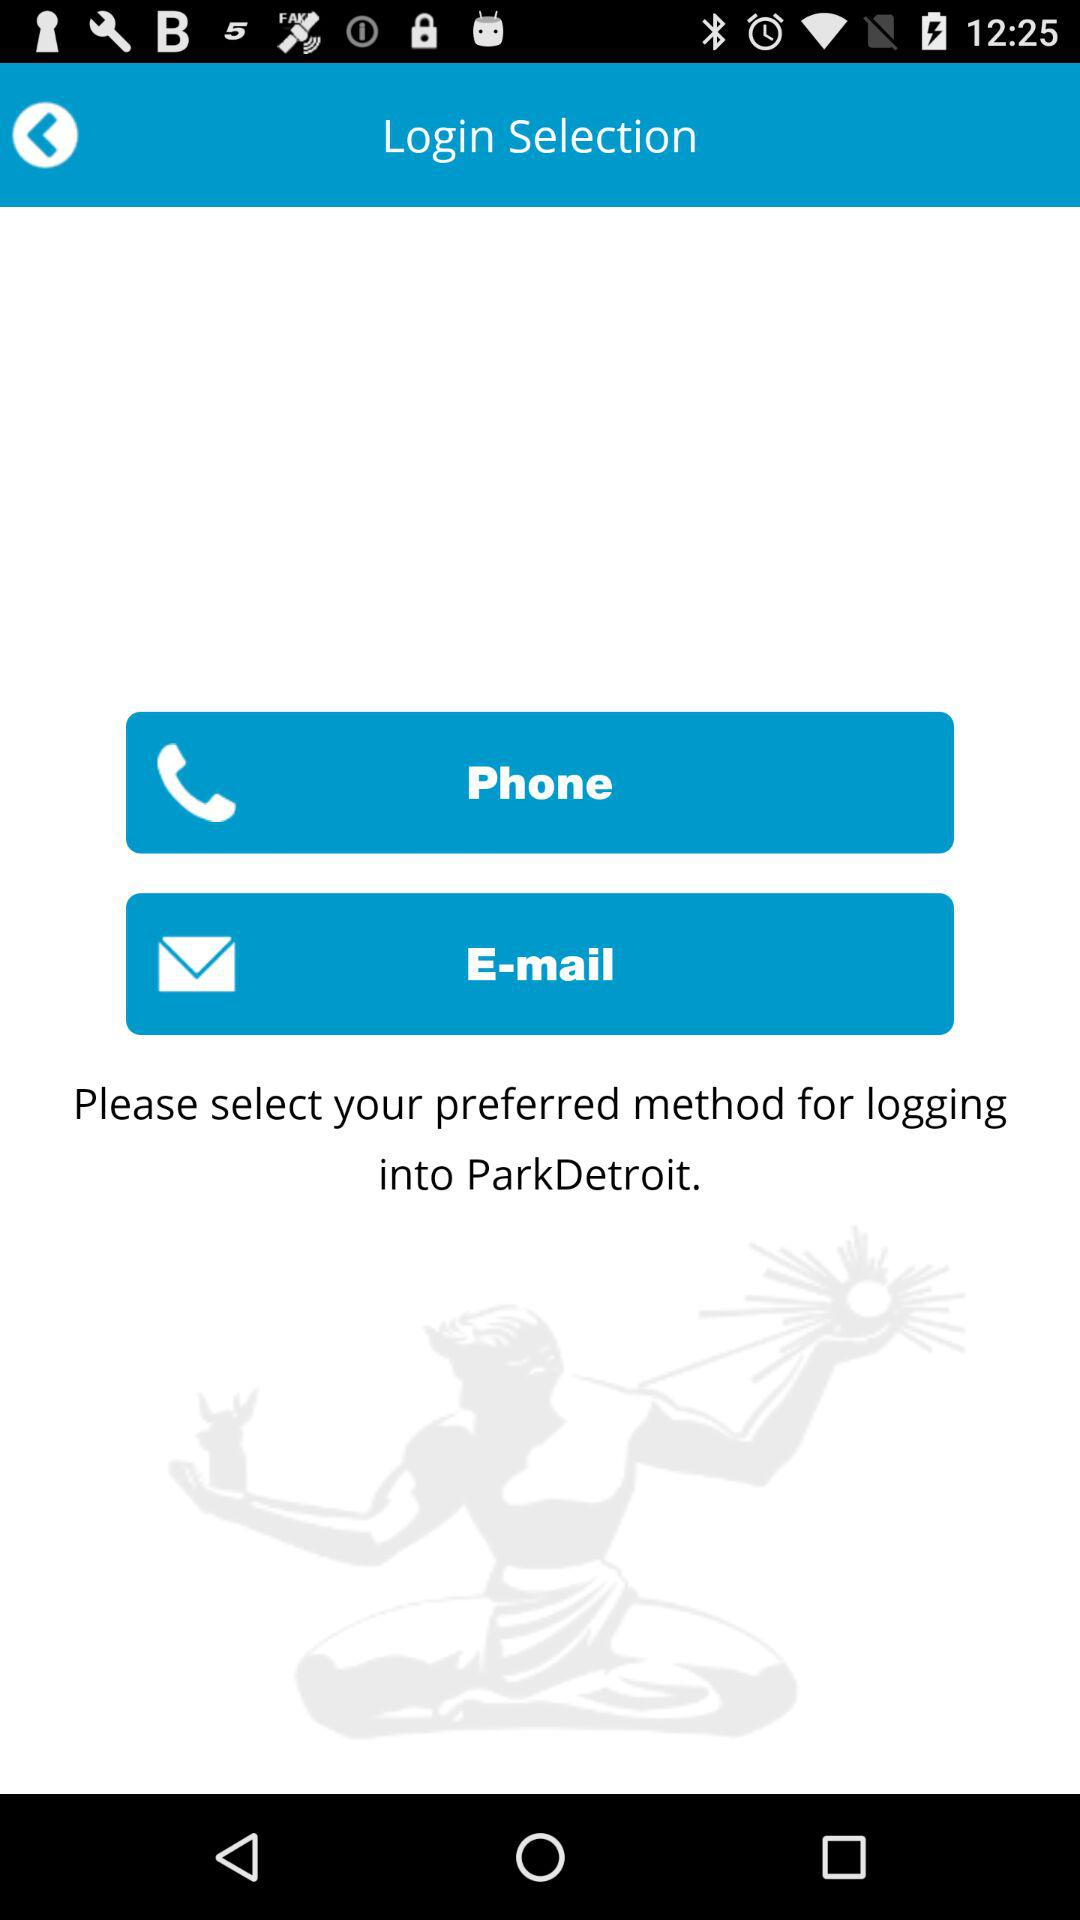Through which method can we log in? You can log in through the "Phone" and "E-mail" methods. 